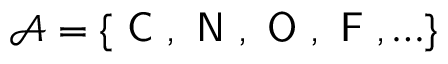<formula> <loc_0><loc_0><loc_500><loc_500>\mathcal { A } = \{ C , N , O , F , \dots \}</formula> 